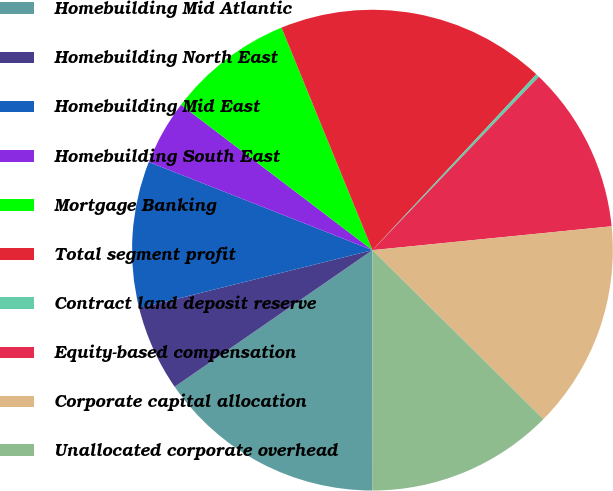Convert chart to OTSL. <chart><loc_0><loc_0><loc_500><loc_500><pie_chart><fcel>Homebuilding Mid Atlantic<fcel>Homebuilding North East<fcel>Homebuilding Mid East<fcel>Homebuilding South East<fcel>Mortgage Banking<fcel>Total segment profit<fcel>Contract land deposit reserve<fcel>Equity-based compensation<fcel>Corporate capital allocation<fcel>Unallocated corporate overhead<nl><fcel>15.36%<fcel>5.74%<fcel>9.86%<fcel>4.36%<fcel>8.49%<fcel>18.11%<fcel>0.24%<fcel>11.24%<fcel>13.99%<fcel>12.61%<nl></chart> 